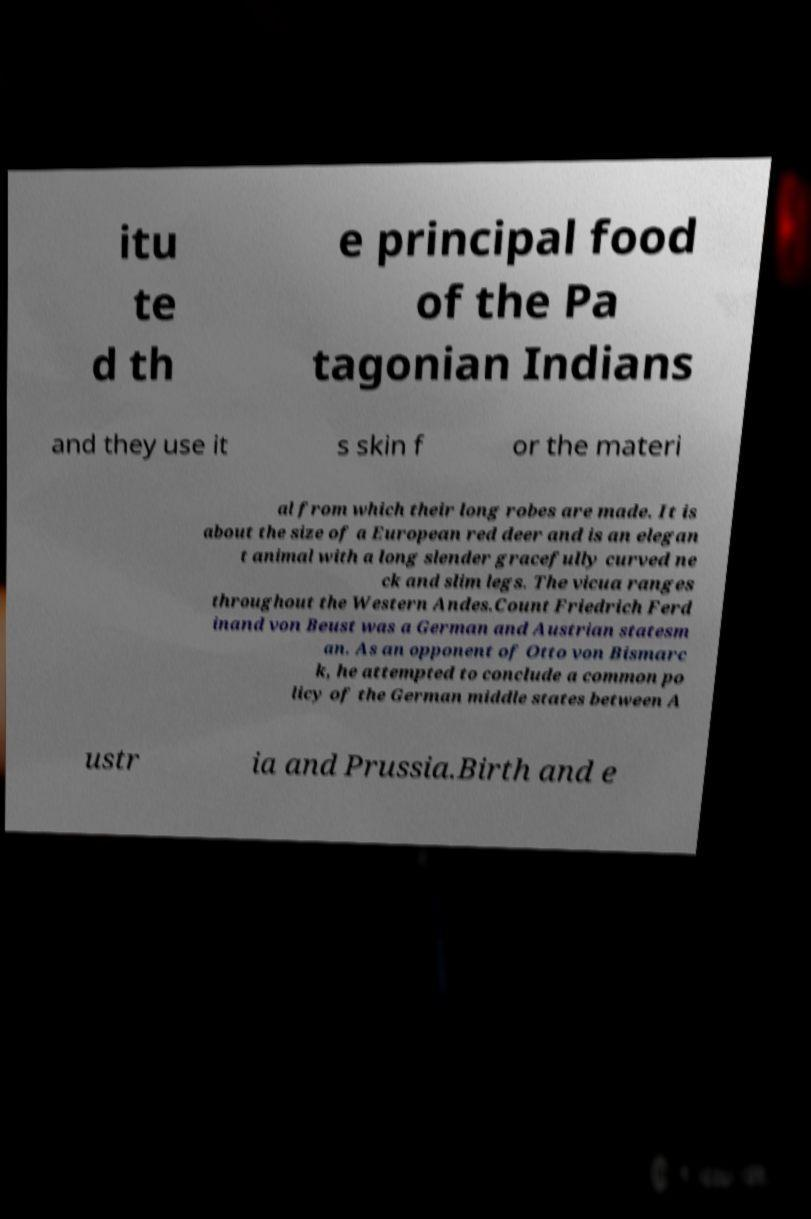There's text embedded in this image that I need extracted. Can you transcribe it verbatim? itu te d th e principal food of the Pa tagonian Indians and they use it s skin f or the materi al from which their long robes are made. It is about the size of a European red deer and is an elegan t animal with a long slender gracefully curved ne ck and slim legs. The vicua ranges throughout the Western Andes.Count Friedrich Ferd inand von Beust was a German and Austrian statesm an. As an opponent of Otto von Bismarc k, he attempted to conclude a common po licy of the German middle states between A ustr ia and Prussia.Birth and e 